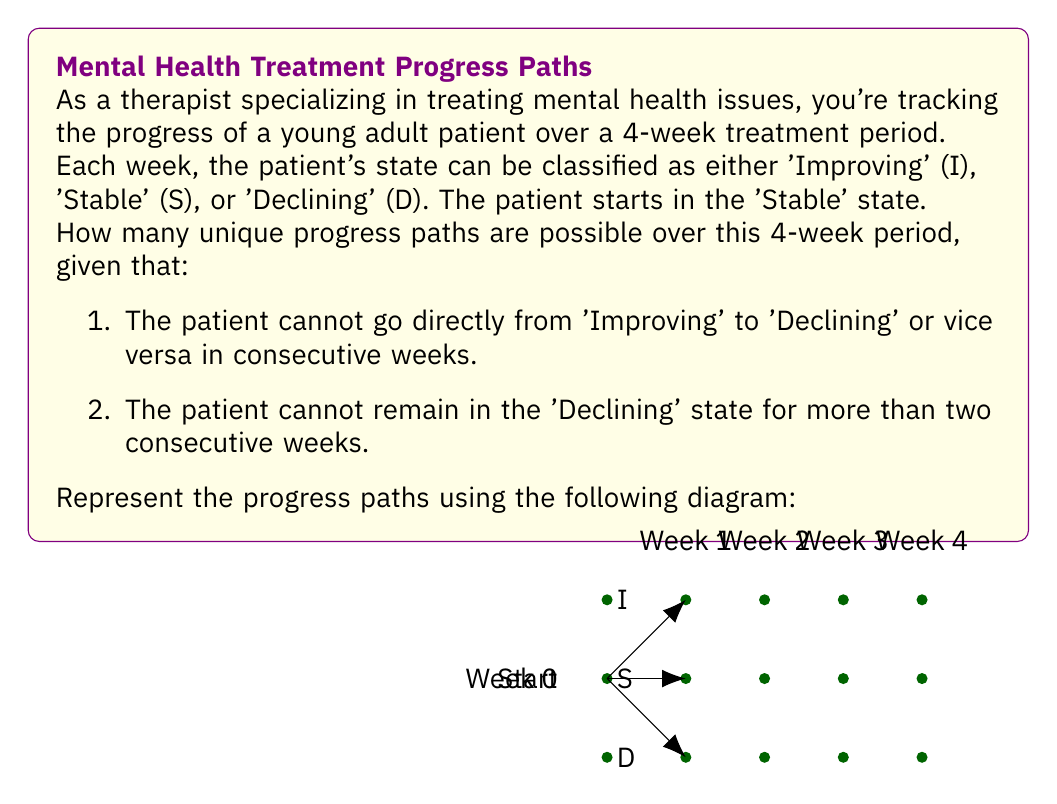Can you solve this math problem? Let's approach this step-by-step:

1) First, we need to define our states:
   I: Improving
   S: Stable
   D: Declining

2) We start at state S (Stable) in Week 0.

3) Let's define functions for the number of paths ending in each state at each week:
   $I(n)$: number of paths ending in I at week n
   $S(n)$: number of paths ending in S at week n
   $D(n)$: number of paths ending in D at week n

4) Initial conditions (Week 0):
   $I(0) = 0$, $S(0) = 1$, $D(0) = 0$

5) For Week 1:
   $I(1) = 1$ (S → I)
   $S(1) = 1$ (S → S)
   $D(1) = 1$ (S → D)

6) For subsequent weeks, we can use recurrence relations:
   $I(n) = I(n-1) + S(n-1)$
   $S(n) = I(n-1) + S(n-1) + D(n-1)$
   $D(n) = S(n-1) + D(n-1)$ if $n = 2$
   $D(n) = S(n-1)$ if $n > 2$ (due to the 2-week limit on declining state)

7) Calculating for each week:
   Week 2:
   $I(2) = I(1) + S(1) = 1 + 1 = 2$
   $S(2) = I(1) + S(1) + D(1) = 1 + 1 + 1 = 3$
   $D(2) = S(1) + D(1) = 1 + 1 = 2$

   Week 3:
   $I(3) = I(2) + S(2) = 2 + 3 = 5$
   $S(3) = I(2) + S(2) + D(2) = 2 + 3 + 2 = 7$
   $D(3) = S(2) = 3$

   Week 4:
   $I(4) = I(3) + S(3) = 5 + 7 = 12$
   $S(4) = I(3) + S(3) + D(3) = 5 + 7 + 3 = 15$
   $D(4) = S(3) = 7$

8) The total number of unique paths is the sum of paths ending in each state at Week 4:
   Total = $I(4) + S(4) + D(4) = 12 + 15 + 7 = 34$

Therefore, there are 34 unique progress paths over this 4-week period.
Answer: 34 